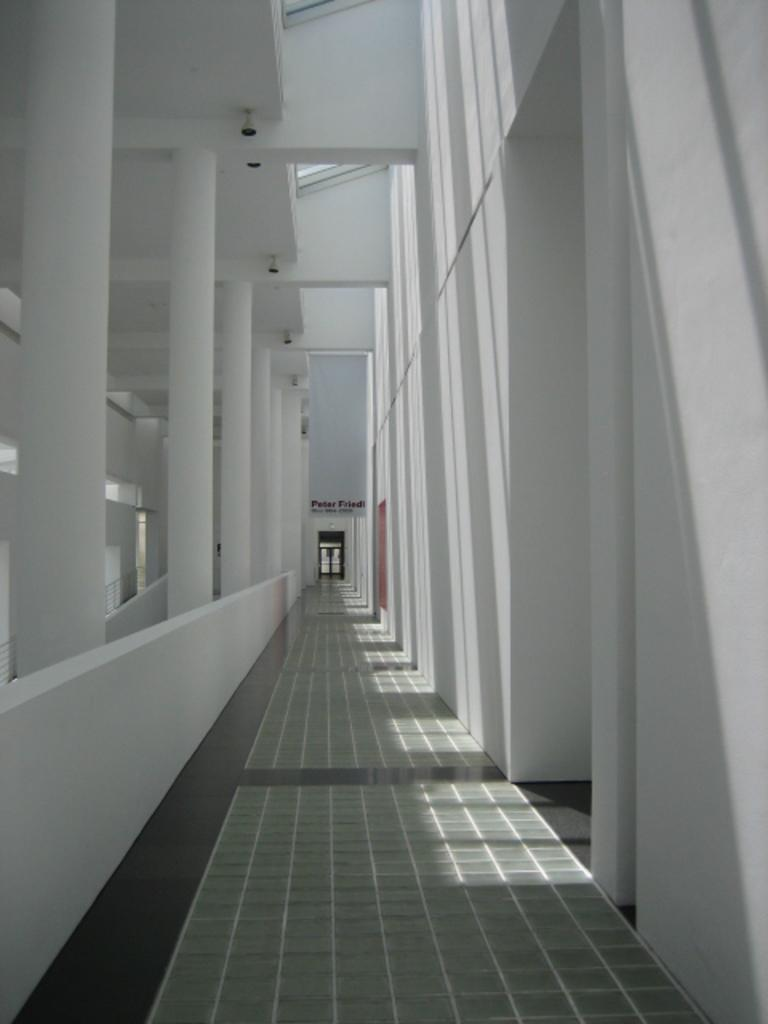Where was the image taken? The image is taken inside a building. What can be seen in the middle of the image? There are pillars, a wall, a floor, lights, and a roof in the middle of the image. What is visible in the background of the image? There is a room and text in the background of the image. Can you see a tree growing through the roof in the image? No, there is no tree visible in the image. Is there a snail crawling on the wall in the image? No, there is no snail present in the image. 